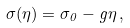<formula> <loc_0><loc_0><loc_500><loc_500>\sigma ( \eta ) = \sigma _ { 0 } - g \eta \, ,</formula> 